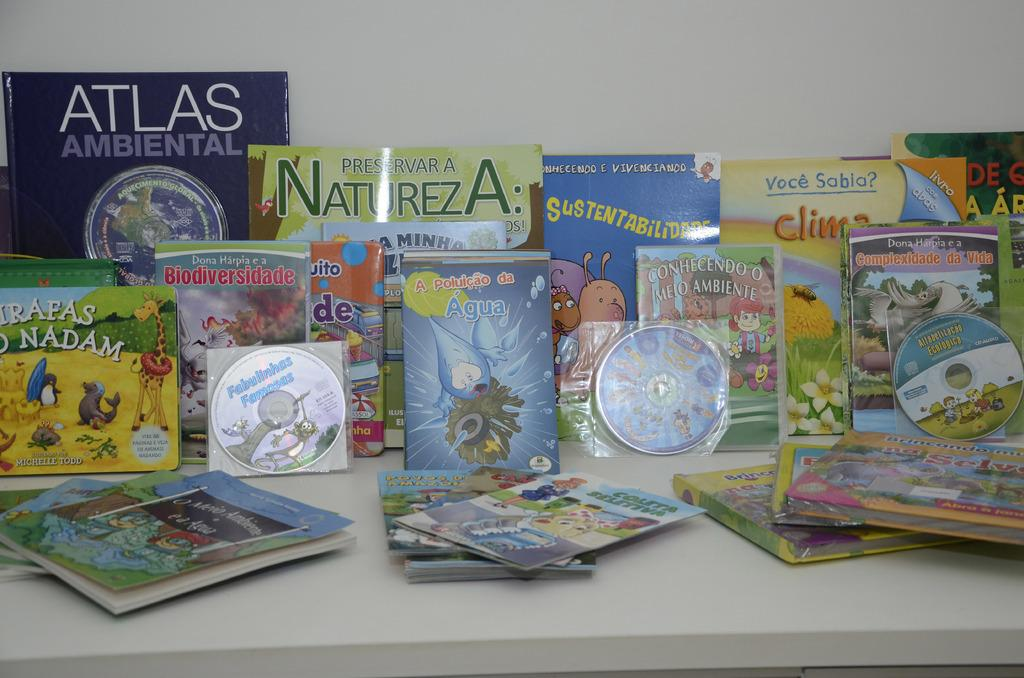<image>
Share a concise interpretation of the image provided. A number of books on a table including one that reads "Atlas Ambiental." 